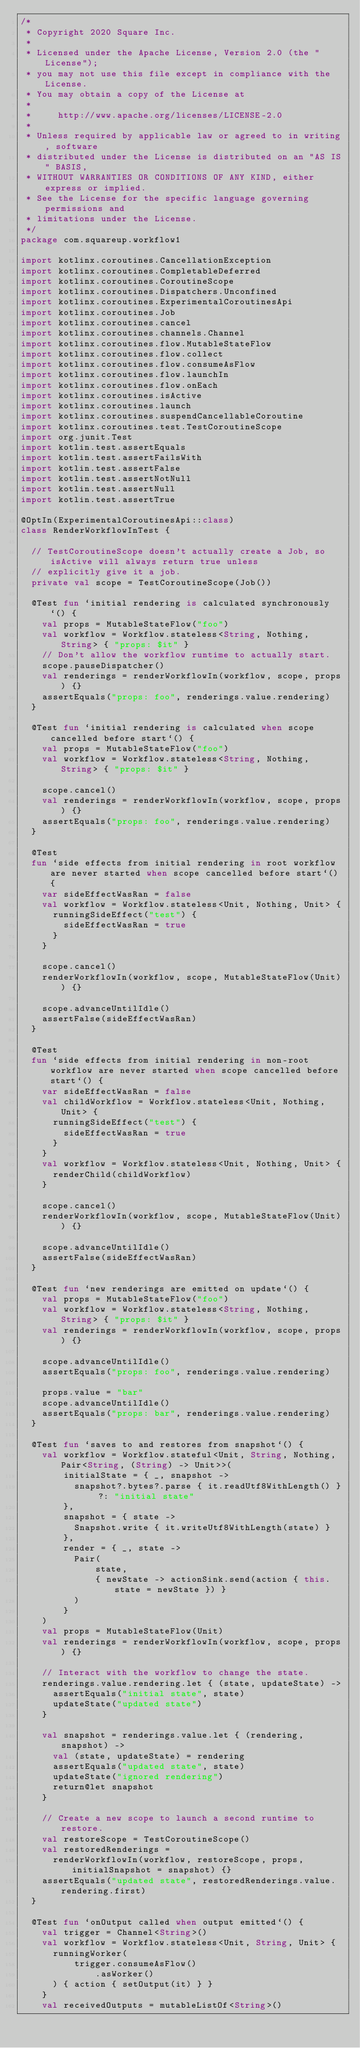<code> <loc_0><loc_0><loc_500><loc_500><_Kotlin_>/*
 * Copyright 2020 Square Inc.
 *
 * Licensed under the Apache License, Version 2.0 (the "License");
 * you may not use this file except in compliance with the License.
 * You may obtain a copy of the License at
 *
 *     http://www.apache.org/licenses/LICENSE-2.0
 *
 * Unless required by applicable law or agreed to in writing, software
 * distributed under the License is distributed on an "AS IS" BASIS,
 * WITHOUT WARRANTIES OR CONDITIONS OF ANY KIND, either express or implied.
 * See the License for the specific language governing permissions and
 * limitations under the License.
 */
package com.squareup.workflow1

import kotlinx.coroutines.CancellationException
import kotlinx.coroutines.CompletableDeferred
import kotlinx.coroutines.CoroutineScope
import kotlinx.coroutines.Dispatchers.Unconfined
import kotlinx.coroutines.ExperimentalCoroutinesApi
import kotlinx.coroutines.Job
import kotlinx.coroutines.cancel
import kotlinx.coroutines.channels.Channel
import kotlinx.coroutines.flow.MutableStateFlow
import kotlinx.coroutines.flow.collect
import kotlinx.coroutines.flow.consumeAsFlow
import kotlinx.coroutines.flow.launchIn
import kotlinx.coroutines.flow.onEach
import kotlinx.coroutines.isActive
import kotlinx.coroutines.launch
import kotlinx.coroutines.suspendCancellableCoroutine
import kotlinx.coroutines.test.TestCoroutineScope
import org.junit.Test
import kotlin.test.assertEquals
import kotlin.test.assertFailsWith
import kotlin.test.assertFalse
import kotlin.test.assertNotNull
import kotlin.test.assertNull
import kotlin.test.assertTrue

@OptIn(ExperimentalCoroutinesApi::class)
class RenderWorkflowInTest {

  // TestCoroutineScope doesn't actually create a Job, so isActive will always return true unless
  // explicitly give it a job.
  private val scope = TestCoroutineScope(Job())

  @Test fun `initial rendering is calculated synchronously`() {
    val props = MutableStateFlow("foo")
    val workflow = Workflow.stateless<String, Nothing, String> { "props: $it" }
    // Don't allow the workflow runtime to actually start.
    scope.pauseDispatcher()
    val renderings = renderWorkflowIn(workflow, scope, props) {}
    assertEquals("props: foo", renderings.value.rendering)
  }

  @Test fun `initial rendering is calculated when scope cancelled before start`() {
    val props = MutableStateFlow("foo")
    val workflow = Workflow.stateless<String, Nothing, String> { "props: $it" }

    scope.cancel()
    val renderings = renderWorkflowIn(workflow, scope, props) {}
    assertEquals("props: foo", renderings.value.rendering)
  }

  @Test
  fun `side effects from initial rendering in root workflow are never started when scope cancelled before start`() {
    var sideEffectWasRan = false
    val workflow = Workflow.stateless<Unit, Nothing, Unit> {
      runningSideEffect("test") {
        sideEffectWasRan = true
      }
    }

    scope.cancel()
    renderWorkflowIn(workflow, scope, MutableStateFlow(Unit)) {}

    scope.advanceUntilIdle()
    assertFalse(sideEffectWasRan)
  }

  @Test
  fun `side effects from initial rendering in non-root workflow are never started when scope cancelled before start`() {
    var sideEffectWasRan = false
    val childWorkflow = Workflow.stateless<Unit, Nothing, Unit> {
      runningSideEffect("test") {
        sideEffectWasRan = true
      }
    }
    val workflow = Workflow.stateless<Unit, Nothing, Unit> {
      renderChild(childWorkflow)
    }

    scope.cancel()
    renderWorkflowIn(workflow, scope, MutableStateFlow(Unit)) {}

    scope.advanceUntilIdle()
    assertFalse(sideEffectWasRan)
  }

  @Test fun `new renderings are emitted on update`() {
    val props = MutableStateFlow("foo")
    val workflow = Workflow.stateless<String, Nothing, String> { "props: $it" }
    val renderings = renderWorkflowIn(workflow, scope, props) {}

    scope.advanceUntilIdle()
    assertEquals("props: foo", renderings.value.rendering)

    props.value = "bar"
    scope.advanceUntilIdle()
    assertEquals("props: bar", renderings.value.rendering)
  }

  @Test fun `saves to and restores from snapshot`() {
    val workflow = Workflow.stateful<Unit, String, Nothing, Pair<String, (String) -> Unit>>(
        initialState = { _, snapshot ->
          snapshot?.bytes?.parse { it.readUtf8WithLength() } ?: "initial state"
        },
        snapshot = { state ->
          Snapshot.write { it.writeUtf8WithLength(state) }
        },
        render = { _, state ->
          Pair(
              state,
              { newState -> actionSink.send(action { this.state = newState }) }
          )
        }
    )
    val props = MutableStateFlow(Unit)
    val renderings = renderWorkflowIn(workflow, scope, props) {}

    // Interact with the workflow to change the state.
    renderings.value.rendering.let { (state, updateState) ->
      assertEquals("initial state", state)
      updateState("updated state")
    }

    val snapshot = renderings.value.let { (rendering, snapshot) ->
      val (state, updateState) = rendering
      assertEquals("updated state", state)
      updateState("ignored rendering")
      return@let snapshot
    }

    // Create a new scope to launch a second runtime to restore.
    val restoreScope = TestCoroutineScope()
    val restoredRenderings =
      renderWorkflowIn(workflow, restoreScope, props, initialSnapshot = snapshot) {}
    assertEquals("updated state", restoredRenderings.value.rendering.first)
  }

  @Test fun `onOutput called when output emitted`() {
    val trigger = Channel<String>()
    val workflow = Workflow.stateless<Unit, String, Unit> {
      runningWorker(
          trigger.consumeAsFlow()
              .asWorker()
      ) { action { setOutput(it) } }
    }
    val receivedOutputs = mutableListOf<String>()</code> 